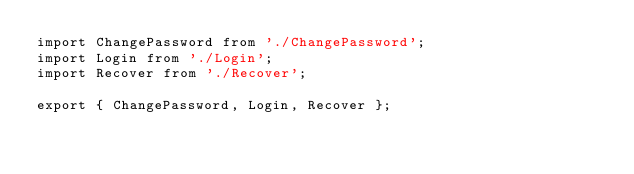Convert code to text. <code><loc_0><loc_0><loc_500><loc_500><_JavaScript_>import ChangePassword from './ChangePassword';
import Login from './Login';
import Recover from './Recover';

export { ChangePassword, Login, Recover };
</code> 